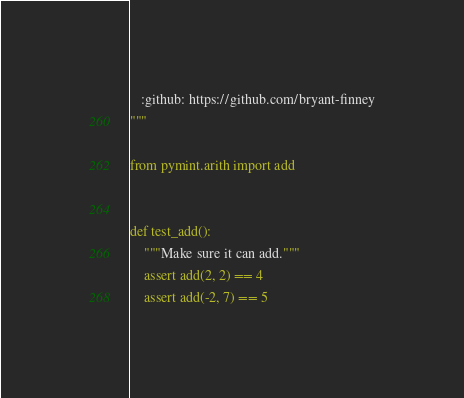<code> <loc_0><loc_0><loc_500><loc_500><_Python_>   :github: https://github.com/bryant-finney
"""

from pymint.arith import add


def test_add():
    """Make sure it can add."""
    assert add(2, 2) == 4
    assert add(-2, 7) == 5
</code> 